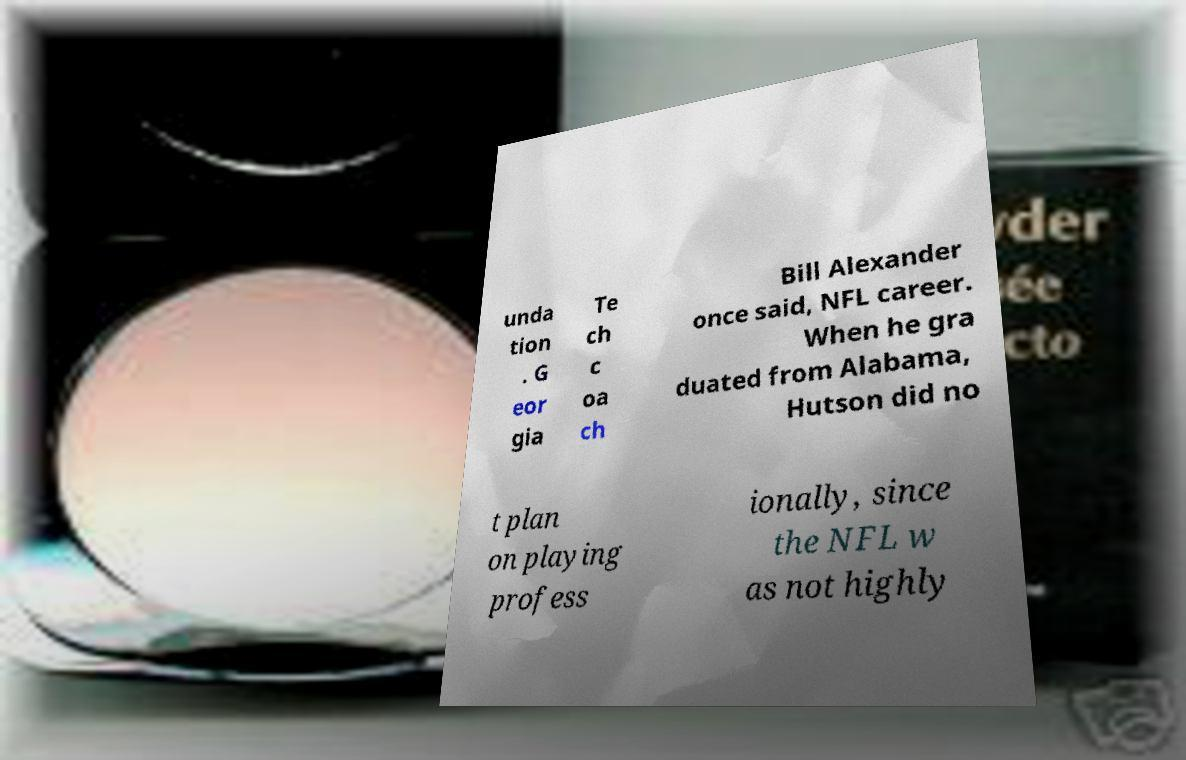Please read and relay the text visible in this image. What does it say? unda tion . G eor gia Te ch c oa ch Bill Alexander once said, NFL career. When he gra duated from Alabama, Hutson did no t plan on playing profess ionally, since the NFL w as not highly 